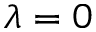Convert formula to latex. <formula><loc_0><loc_0><loc_500><loc_500>\lambda = 0</formula> 